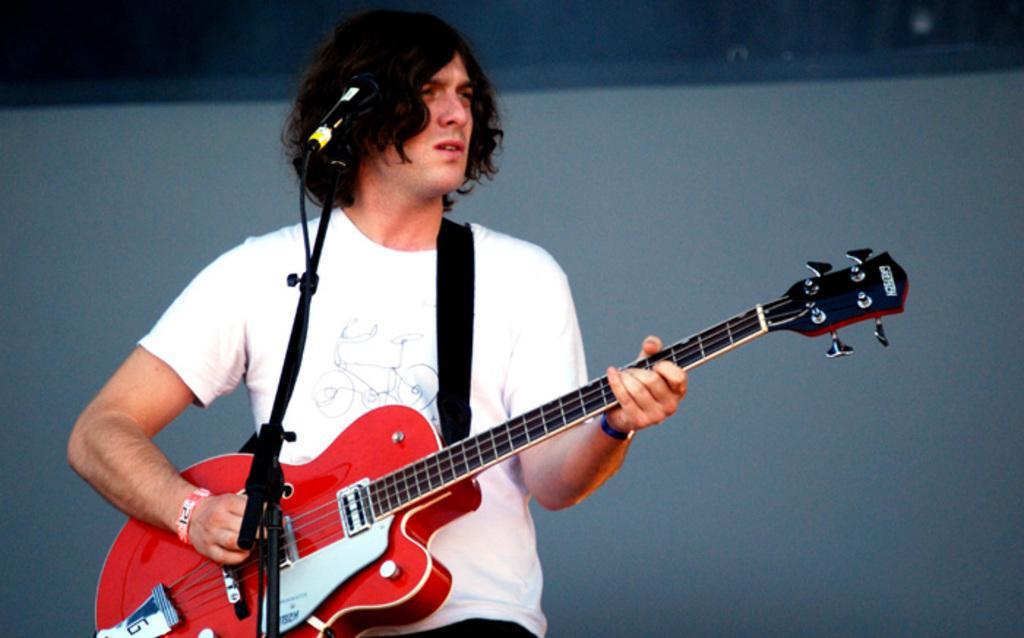Could you give a brief overview of what you see in this image? In this image we can see a man wearing white t shirt is holding a guitar in his hands and playing it. There is a mic in front of him. 